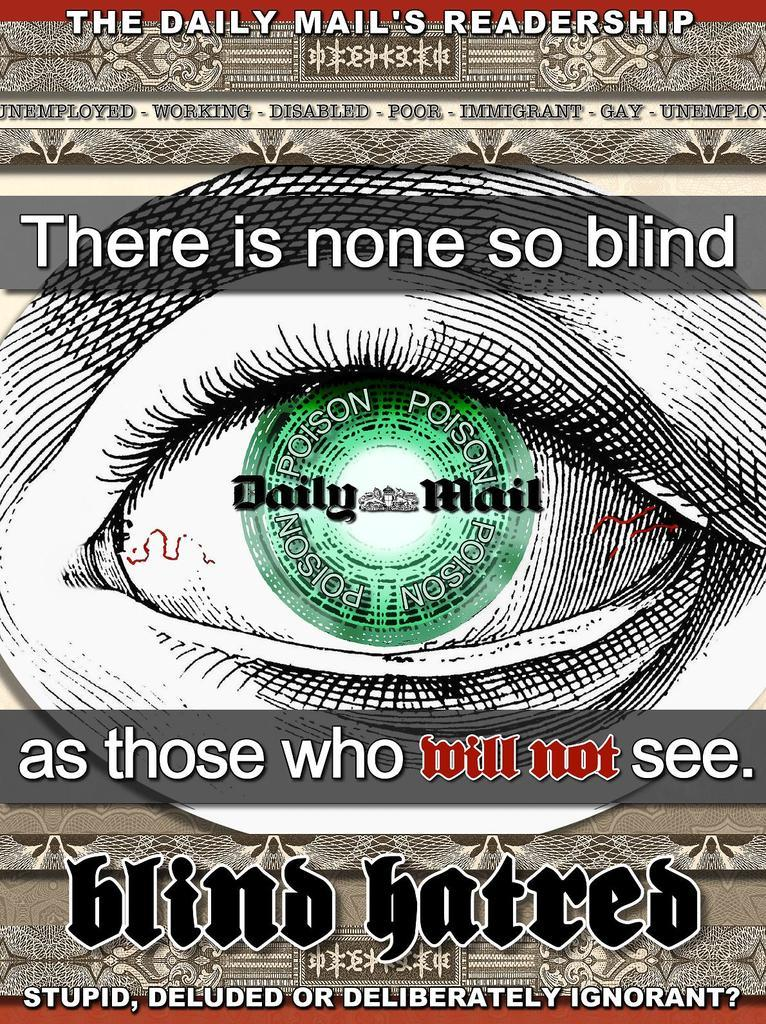What is the main subject in the center of the image? There is a poster in the center of the image. What is depicted on the poster? The poster contains an image of one eye. Are there any additional design elements on the poster? Yes, the poster has some design elements. Is there any text on the poster? Yes, the poster has some text. How many boats are visible in the image? There are no boats present in the image; it features a poster with an image of one eye. What is the title of the poster in the image? There is no title mentioned in the provided facts, so we cannot determine the title of the poster. 